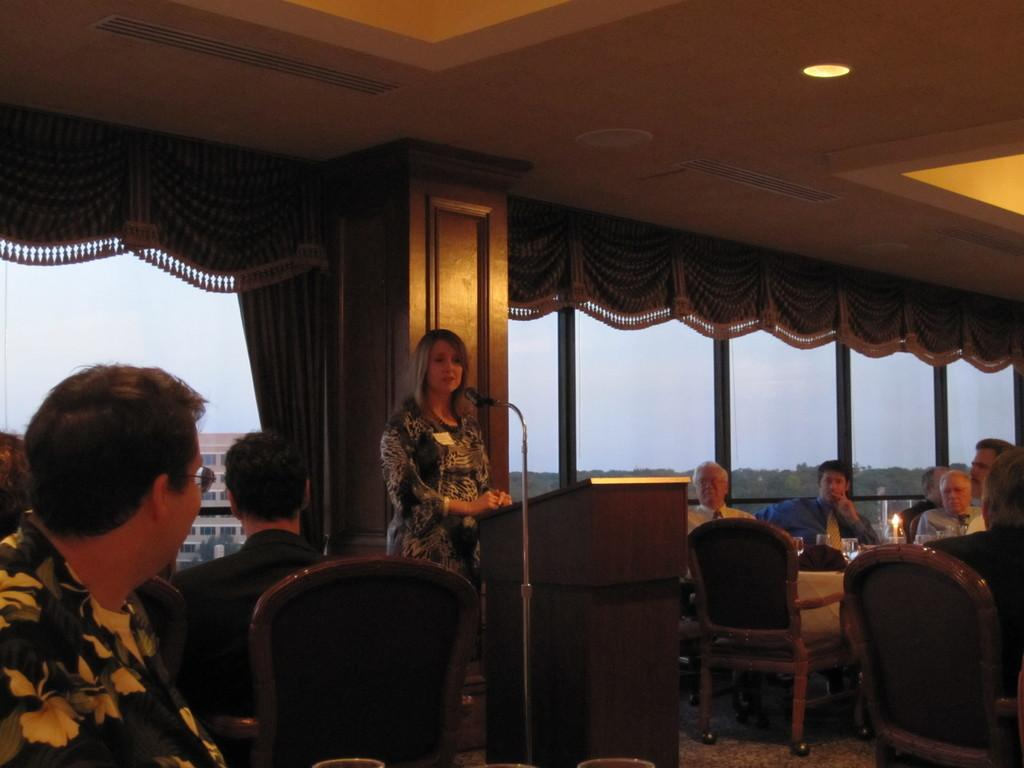What is the lady in the image doing? The lady is standing and talking in front of a mic. What is the setting of the image? There is a wooden table in the image, and people are sitting at the table. What are the people at the table doing? The people at the table are listening to the lady. Is there a record player visible in the image? No, there is no record player present in the image. Can you describe the pleasure experienced by the people listening to the lady? The provided facts do not mention any information about the pleasure experienced by the people listening to the lady. --- Facts: 1. There is a car in the image. 2. The car is parked on the street. 3. There are trees lining the street. 4. The sky is visible in the image. 5. The car has a red color. Absurd Topics: parrot, dance, ocean Conversation: What is the main subject of the image? The main subject of the image is a car. Where is the car located in the image? The car is parked on the street. What can be seen alongside the street in the image? There are trees lining the street. What is visible in the background of the image? The sky is visible in the image. What color is the car in the image? The car has a red color. Reasoning: Let's think step by step in order to produce the conversation. We start by identifying the main subject in the image, which is the car. Then, we describe the location of the car, noting that it is parked on the street. Next, we mention the presence of trees lining the street, which adds context to the setting. We then describe the background of the image, which includes the sky. Finally, we focus on the color of the car, which is red. Absurd Question/Answer: Can you tell me how many parrots are sitting on the car in the image? There are no parrots present in the image. Is there a dance performance happening in the background of the image? No, there is no dance performance visible in the image. 